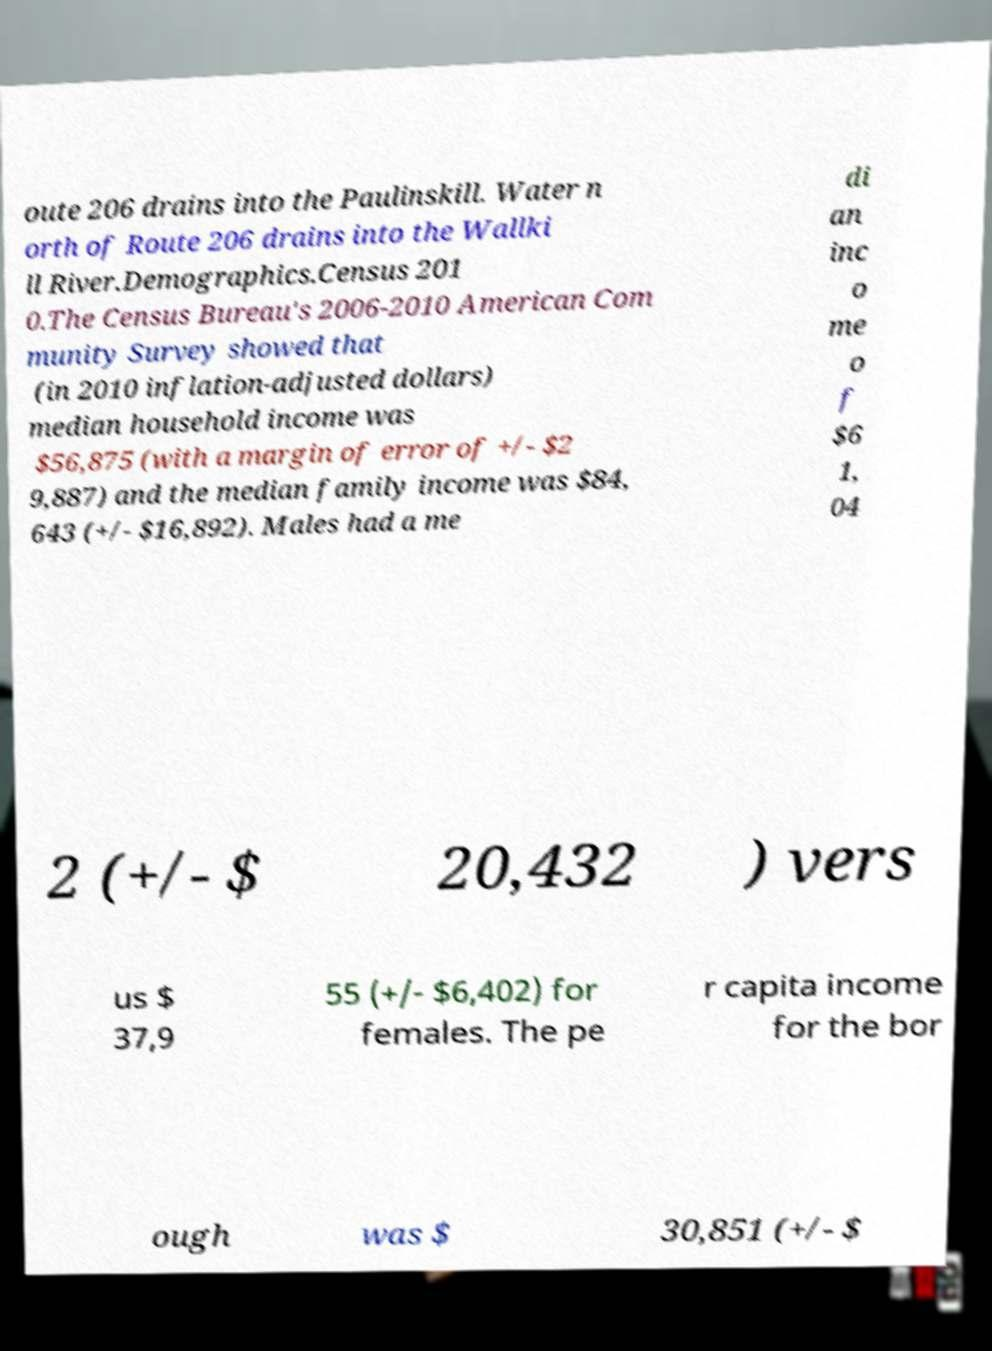Please identify and transcribe the text found in this image. oute 206 drains into the Paulinskill. Water n orth of Route 206 drains into the Wallki ll River.Demographics.Census 201 0.The Census Bureau's 2006-2010 American Com munity Survey showed that (in 2010 inflation-adjusted dollars) median household income was $56,875 (with a margin of error of +/- $2 9,887) and the median family income was $84, 643 (+/- $16,892). Males had a me di an inc o me o f $6 1, 04 2 (+/- $ 20,432 ) vers us $ 37,9 55 (+/- $6,402) for females. The pe r capita income for the bor ough was $ 30,851 (+/- $ 